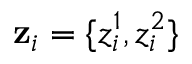Convert formula to latex. <formula><loc_0><loc_0><loc_500><loc_500>\mathbf z _ { i } = \{ z _ { i } ^ { 1 } , z _ { i } ^ { 2 } \}</formula> 